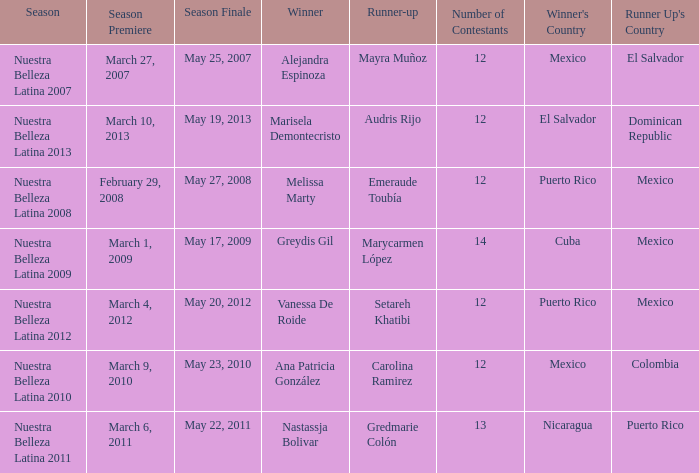What season's premiere had puerto rico winning on May 20, 2012? March 4, 2012. 